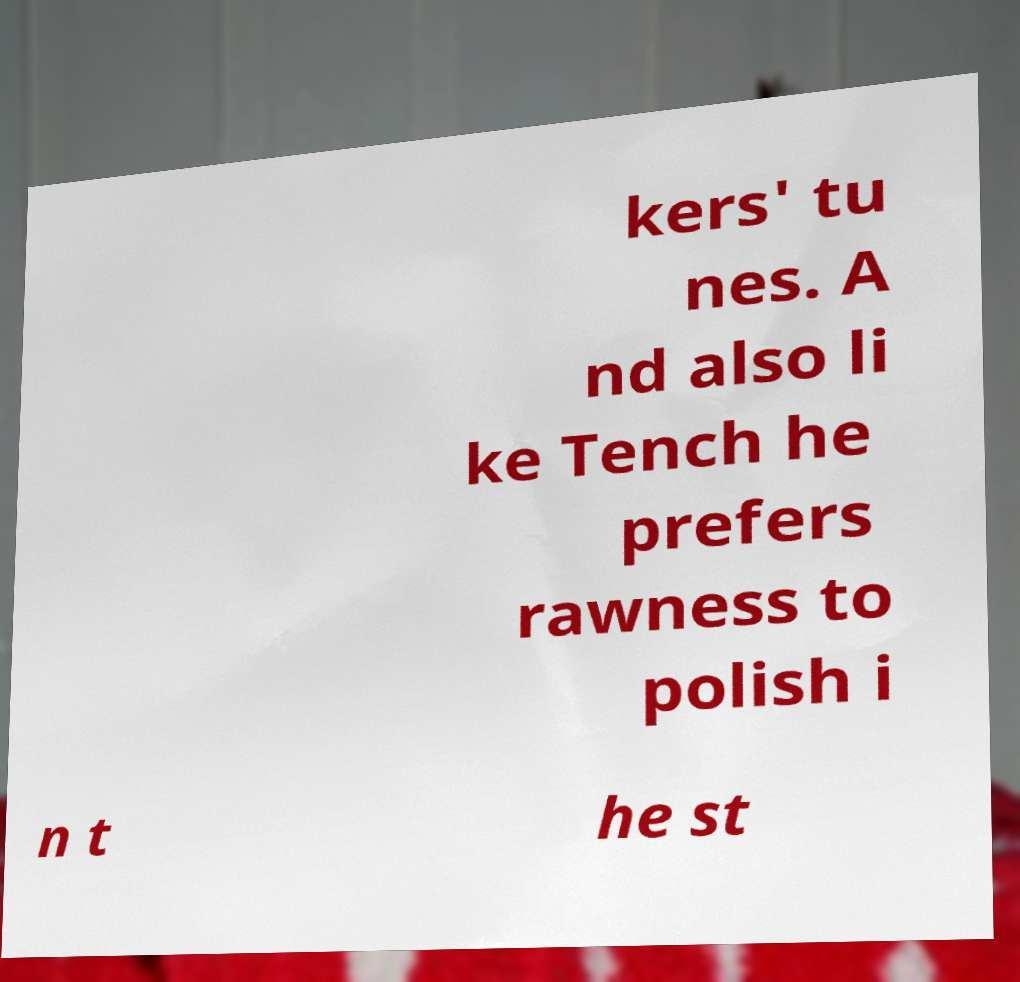Can you accurately transcribe the text from the provided image for me? kers' tu nes. A nd also li ke Tench he prefers rawness to polish i n t he st 